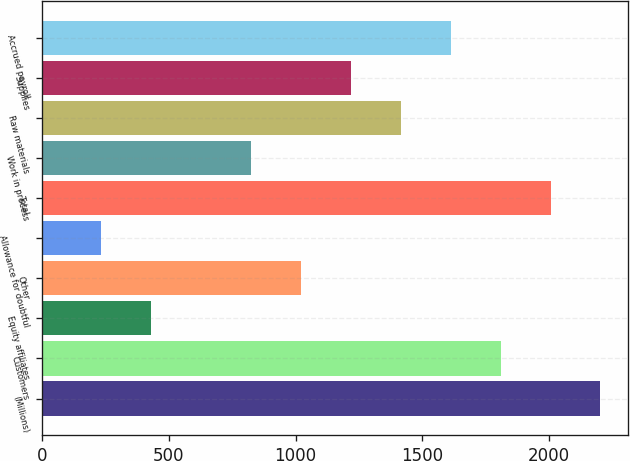<chart> <loc_0><loc_0><loc_500><loc_500><bar_chart><fcel>(Millions)<fcel>Customers<fcel>Equity affiliates<fcel>Other<fcel>Allowance for doubtful<fcel>Total<fcel>Work in process<fcel>Raw materials<fcel>Supplies<fcel>Accrued payroll<nl><fcel>2201.9<fcel>1808.1<fcel>429.8<fcel>1020.5<fcel>232.9<fcel>2005<fcel>823.6<fcel>1414.3<fcel>1217.4<fcel>1611.2<nl></chart> 